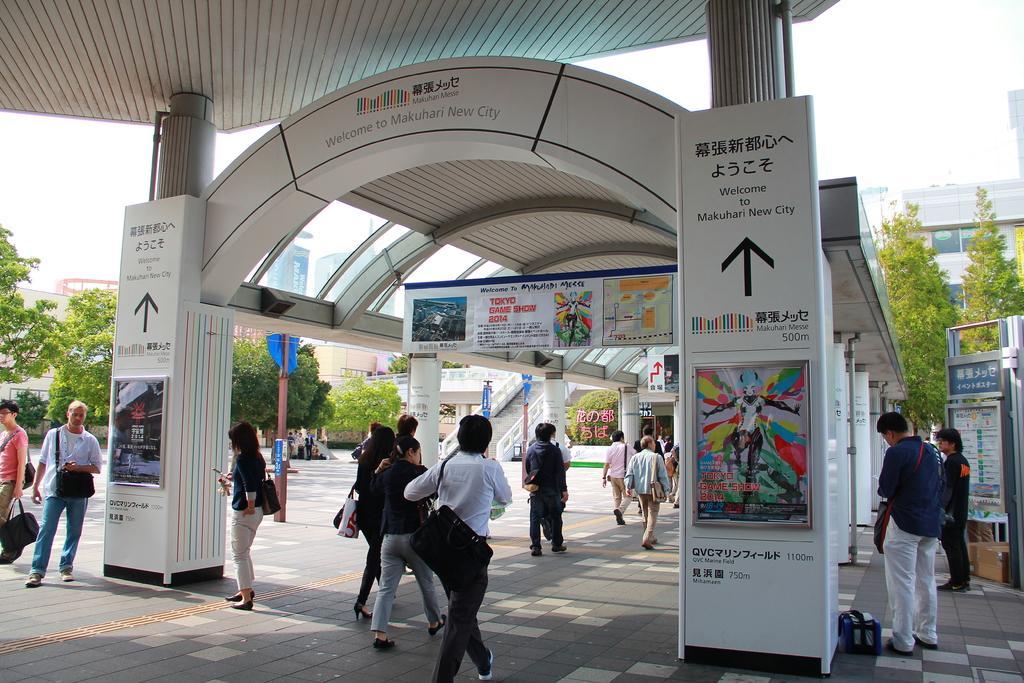Please provide a concise description of this image. In this picture we can see there are some people standing and some people walking on the path. On the left and right side of the people there are boards and banners. On the left side of the people there is a pole, trees, buildings and the sky. 